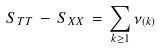<formula> <loc_0><loc_0><loc_500><loc_500>S _ { T T } \, - \, S _ { X X } \, = \, \sum _ { k \geq 1 } \nu _ { ( k ) }</formula> 